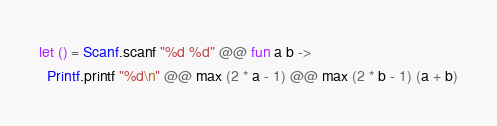<code> <loc_0><loc_0><loc_500><loc_500><_OCaml_>let () = Scanf.scanf "%d %d" @@ fun a b ->
  Printf.printf "%d\n" @@ max (2 * a - 1) @@ max (2 * b - 1) (a + b)</code> 